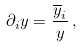Convert formula to latex. <formula><loc_0><loc_0><loc_500><loc_500>\partial _ { i } y = \frac { \overline { y } _ { i } } { y } \, ,</formula> 